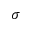<formula> <loc_0><loc_0><loc_500><loc_500>\sigma</formula> 